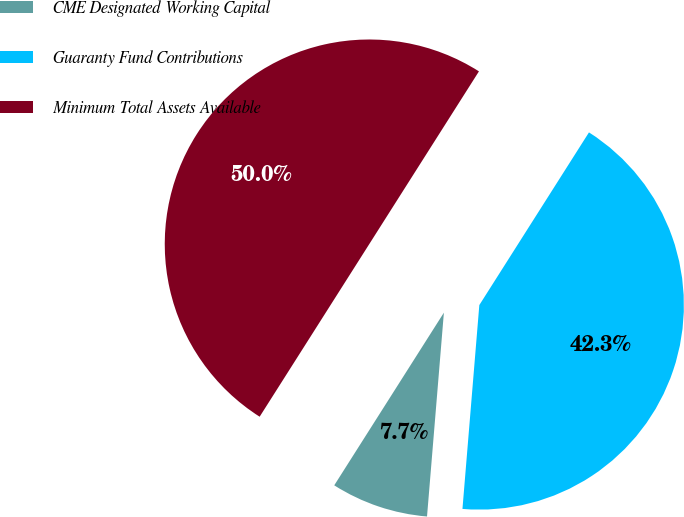<chart> <loc_0><loc_0><loc_500><loc_500><pie_chart><fcel>CME Designated Working Capital<fcel>Guaranty Fund Contributions<fcel>Minimum Total Assets Available<nl><fcel>7.69%<fcel>42.31%<fcel>50.0%<nl></chart> 